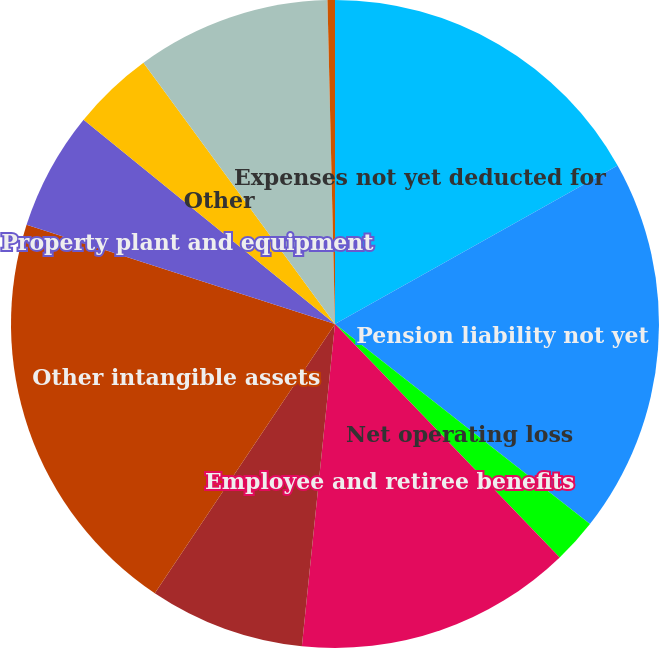<chart> <loc_0><loc_0><loc_500><loc_500><pie_chart><fcel>Expenses not yet deducted for<fcel>Pension liability not yet<fcel>Net operating loss<fcel>Employee and retiree benefits<fcel>Inventory<fcel>Other intangible assets<fcel>Property plant and equipment<fcel>Other<fcel>Net deferred tax (liability)<fcel>Valuation allowance<nl><fcel>16.87%<fcel>18.72%<fcel>2.22%<fcel>13.83%<fcel>7.76%<fcel>20.57%<fcel>5.91%<fcel>4.07%<fcel>9.7%<fcel>0.37%<nl></chart> 